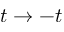Convert formula to latex. <formula><loc_0><loc_0><loc_500><loc_500>t \rightarrow - t</formula> 